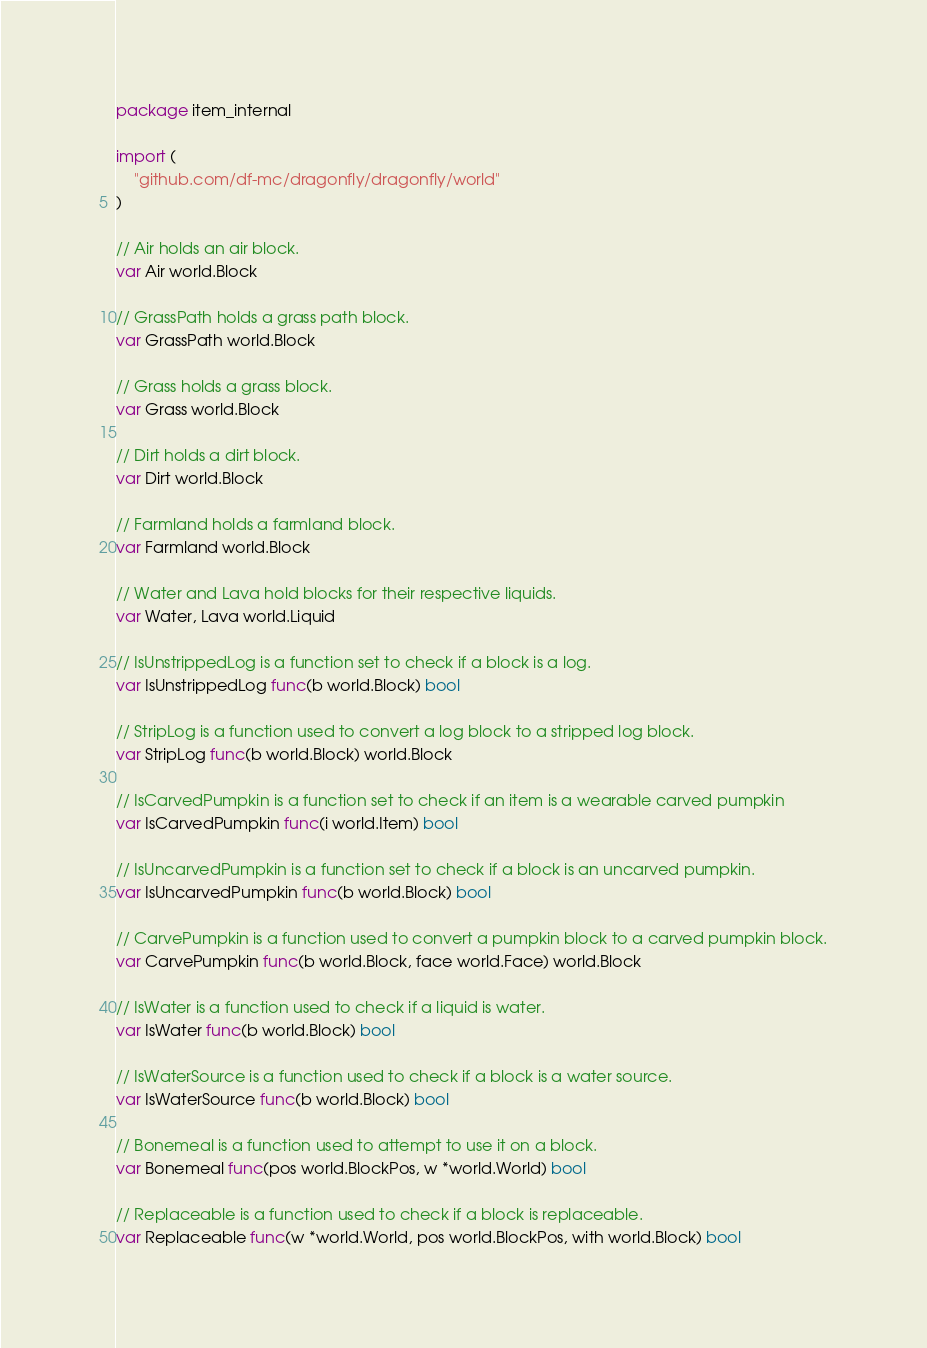<code> <loc_0><loc_0><loc_500><loc_500><_Go_>package item_internal

import (
	"github.com/df-mc/dragonfly/dragonfly/world"
)

// Air holds an air block.
var Air world.Block

// GrassPath holds a grass path block.
var GrassPath world.Block

// Grass holds a grass block.
var Grass world.Block

// Dirt holds a dirt block.
var Dirt world.Block

// Farmland holds a farmland block.
var Farmland world.Block

// Water and Lava hold blocks for their respective liquids.
var Water, Lava world.Liquid

// IsUnstrippedLog is a function set to check if a block is a log.
var IsUnstrippedLog func(b world.Block) bool

// StripLog is a function used to convert a log block to a stripped log block.
var StripLog func(b world.Block) world.Block

// IsCarvedPumpkin is a function set to check if an item is a wearable carved pumpkin
var IsCarvedPumpkin func(i world.Item) bool

// IsUncarvedPumpkin is a function set to check if a block is an uncarved pumpkin.
var IsUncarvedPumpkin func(b world.Block) bool

// CarvePumpkin is a function used to convert a pumpkin block to a carved pumpkin block.
var CarvePumpkin func(b world.Block, face world.Face) world.Block

// IsWater is a function used to check if a liquid is water.
var IsWater func(b world.Block) bool

// IsWaterSource is a function used to check if a block is a water source.
var IsWaterSource func(b world.Block) bool

// Bonemeal is a function used to attempt to use it on a block.
var Bonemeal func(pos world.BlockPos, w *world.World) bool

// Replaceable is a function used to check if a block is replaceable.
var Replaceable func(w *world.World, pos world.BlockPos, with world.Block) bool
</code> 